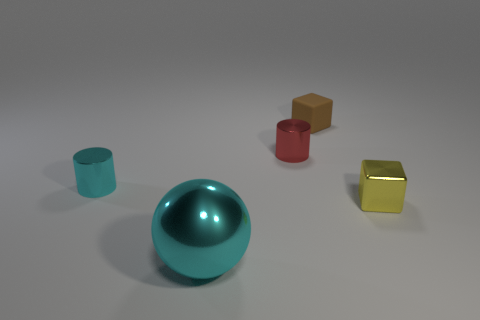Subtract all cyan cylinders. How many cylinders are left? 1 Add 4 small gray rubber objects. How many objects exist? 9 Subtract all cubes. How many objects are left? 3 Subtract 1 spheres. How many spheres are left? 0 Add 2 small purple matte objects. How many small purple matte objects exist? 2 Subtract 0 red spheres. How many objects are left? 5 Subtract all gray cylinders. Subtract all cyan blocks. How many cylinders are left? 2 Subtract all green blocks. How many purple balls are left? 0 Subtract all brown things. Subtract all blocks. How many objects are left? 2 Add 2 small yellow blocks. How many small yellow blocks are left? 3 